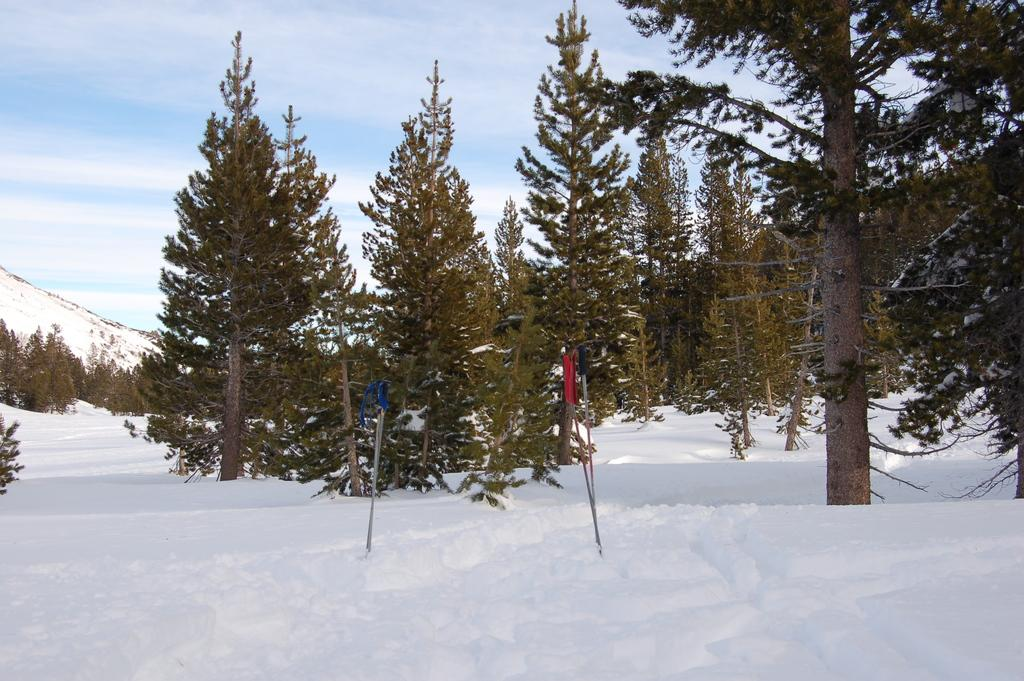What type of vegetation can be seen in the image? There are trees in the image. What is covering the ground in the image? There is snow on the ground in the image. What can be seen on the poles in the image? There is a pole with a blue cloth and a pole with a red cloth in the image. How would you describe the sky in the image? The sky is blue and cloudy in the image. What type of meat is hanging from the trees in the image? There is no meat hanging from the trees in the image; it only features trees, snow, poles, and cloths. What kind of scarecrow can be seen in the image? There is no scarecrow present in the image. 